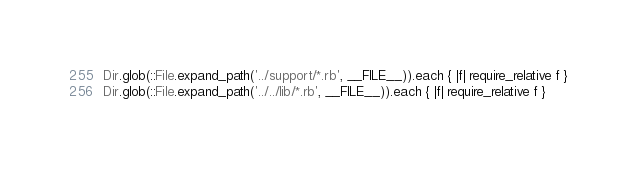<code> <loc_0><loc_0><loc_500><loc_500><_Ruby_>
Dir.glob(::File.expand_path('../support/*.rb', __FILE__)).each { |f| require_relative f }
Dir.glob(::File.expand_path('../../lib/*.rb', __FILE__)).each { |f| require_relative f }

</code> 